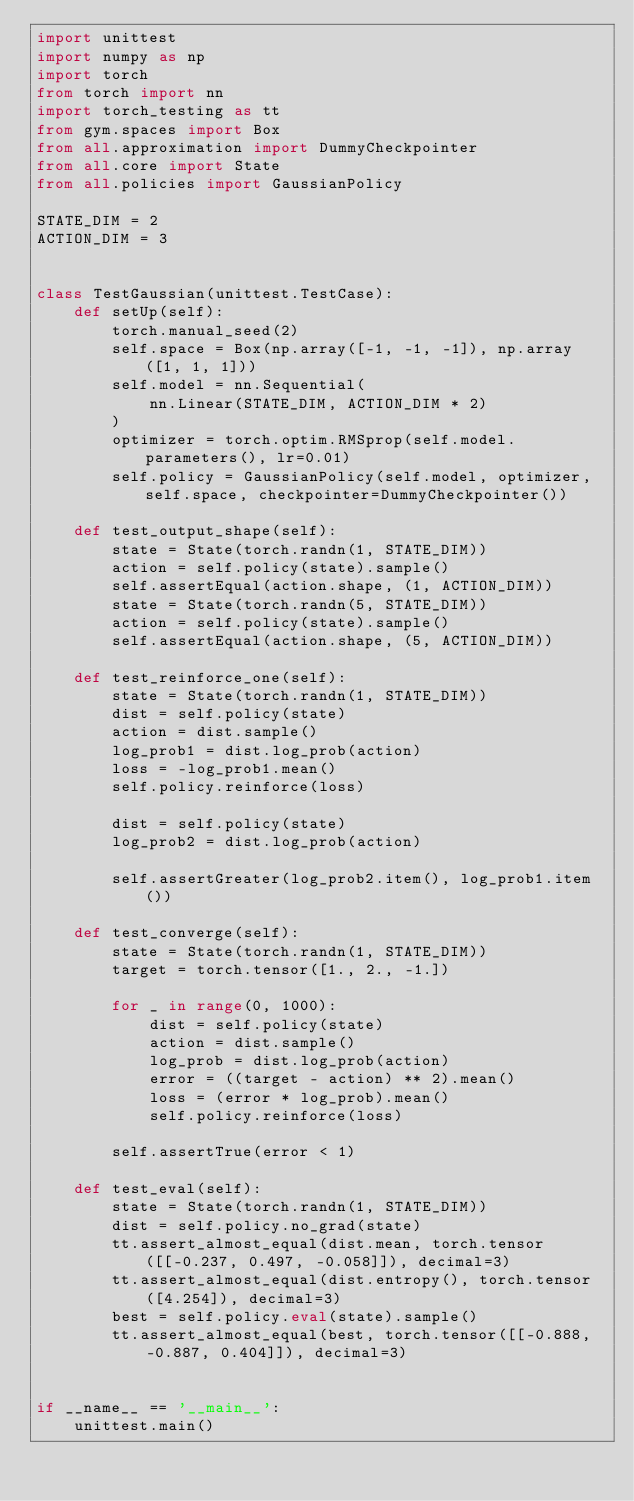Convert code to text. <code><loc_0><loc_0><loc_500><loc_500><_Python_>import unittest
import numpy as np
import torch
from torch import nn
import torch_testing as tt
from gym.spaces import Box
from all.approximation import DummyCheckpointer
from all.core import State
from all.policies import GaussianPolicy

STATE_DIM = 2
ACTION_DIM = 3


class TestGaussian(unittest.TestCase):
    def setUp(self):
        torch.manual_seed(2)
        self.space = Box(np.array([-1, -1, -1]), np.array([1, 1, 1]))
        self.model = nn.Sequential(
            nn.Linear(STATE_DIM, ACTION_DIM * 2)
        )
        optimizer = torch.optim.RMSprop(self.model.parameters(), lr=0.01)
        self.policy = GaussianPolicy(self.model, optimizer, self.space, checkpointer=DummyCheckpointer())

    def test_output_shape(self):
        state = State(torch.randn(1, STATE_DIM))
        action = self.policy(state).sample()
        self.assertEqual(action.shape, (1, ACTION_DIM))
        state = State(torch.randn(5, STATE_DIM))
        action = self.policy(state).sample()
        self.assertEqual(action.shape, (5, ACTION_DIM))

    def test_reinforce_one(self):
        state = State(torch.randn(1, STATE_DIM))
        dist = self.policy(state)
        action = dist.sample()
        log_prob1 = dist.log_prob(action)
        loss = -log_prob1.mean()
        self.policy.reinforce(loss)

        dist = self.policy(state)
        log_prob2 = dist.log_prob(action)

        self.assertGreater(log_prob2.item(), log_prob1.item())

    def test_converge(self):
        state = State(torch.randn(1, STATE_DIM))
        target = torch.tensor([1., 2., -1.])

        for _ in range(0, 1000):
            dist = self.policy(state)
            action = dist.sample()
            log_prob = dist.log_prob(action)
            error = ((target - action) ** 2).mean()
            loss = (error * log_prob).mean()
            self.policy.reinforce(loss)

        self.assertTrue(error < 1)

    def test_eval(self):
        state = State(torch.randn(1, STATE_DIM))
        dist = self.policy.no_grad(state)
        tt.assert_almost_equal(dist.mean, torch.tensor([[-0.237, 0.497, -0.058]]), decimal=3)
        tt.assert_almost_equal(dist.entropy(), torch.tensor([4.254]), decimal=3)
        best = self.policy.eval(state).sample()
        tt.assert_almost_equal(best, torch.tensor([[-0.888, -0.887, 0.404]]), decimal=3)


if __name__ == '__main__':
    unittest.main()
</code> 